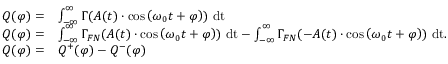<formula> <loc_0><loc_0><loc_500><loc_500>\begin{array} { r l } { Q ( \varphi ) = } & { \int _ { - \infty } ^ { \infty } \Gamma ( A ( t ) \cdot \cos \left ( \omega _ { 0 } t + \varphi \right ) ) d t } \\ { Q ( \varphi ) = } & { \int _ { - \infty } ^ { \infty } \Gamma _ { F N } ( A ( t ) \cdot \cos \left ( \omega _ { 0 } t + \varphi \right ) ) d t - \int _ { - \infty } ^ { \infty } \Gamma _ { F N } ( - A ( t ) \cdot \cos \left ( \omega _ { 0 } t + \varphi \right ) ) d t . } \\ { Q ( \varphi ) = } & { Q ^ { + } ( \varphi ) - Q ^ { - } ( \varphi ) } \end{array}</formula> 